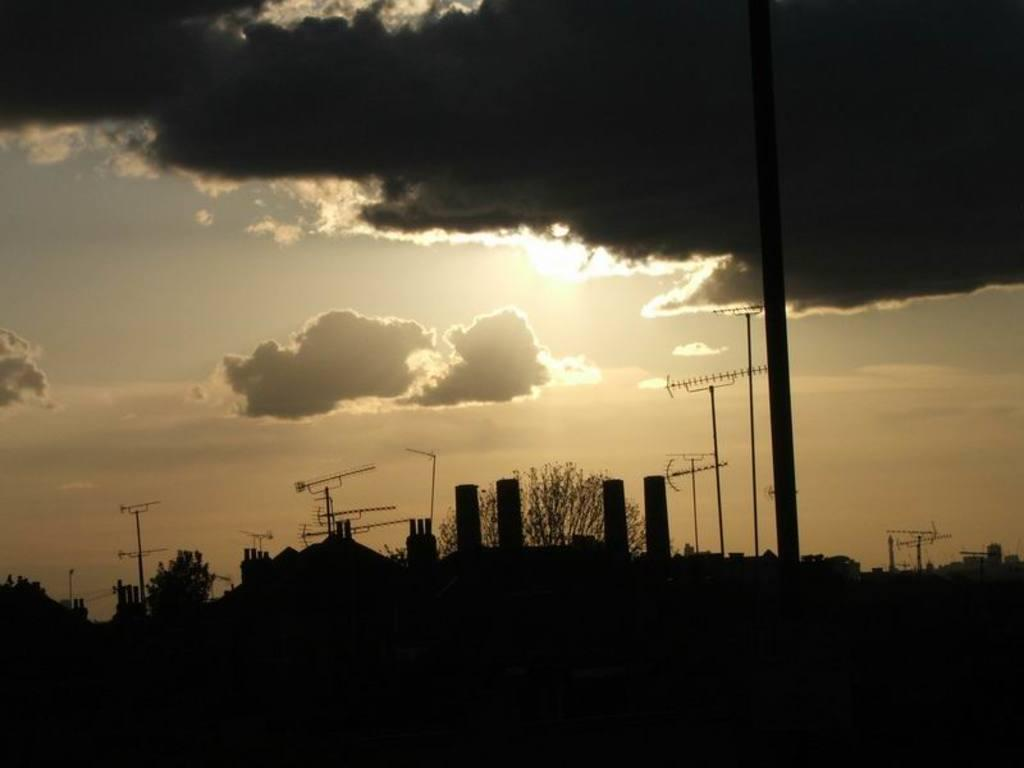What structures can be seen in the image? There are electrical poles in the image. What type of natural elements are present in the image? There are trees in the image. What can be seen in the sky in the image? There are clouds visible in the sky. What type of rose is the spy holding in the image? There is no spy or rose present in the image; it only features electrical poles, trees, and clouds in the sky. 